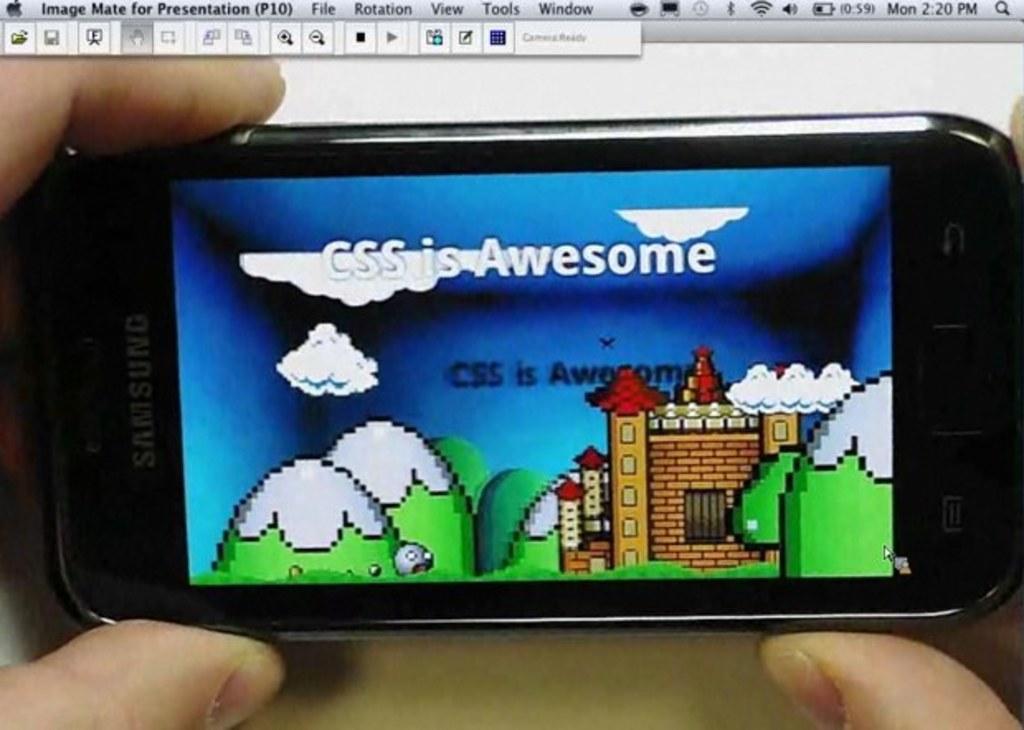In one or two sentences, can you explain what this image depicts? In the picture I can see a person holding a mobile phone which has a picture displayed on it and there is something above it. 